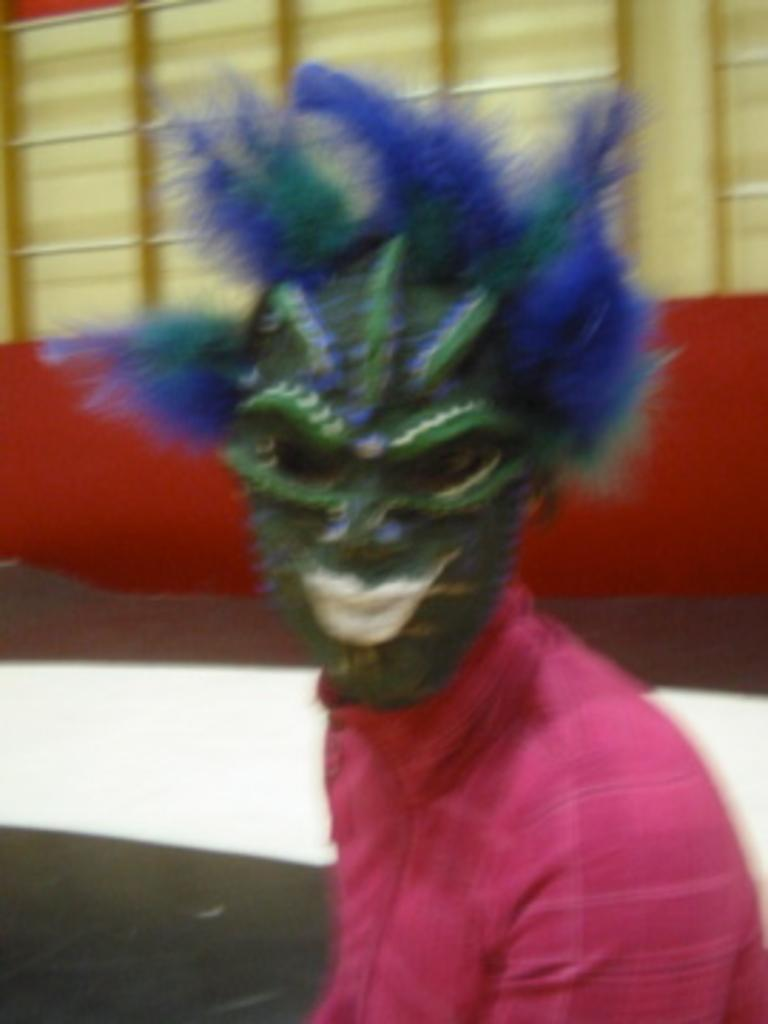Who or what is present in the image? There is a person in the image. What is the person wearing on their face? The person is wearing a mask. What can be seen behind the person in the image? There is a wall in the background of the image. How many kittens are balancing on the person's head in the image? There are no kittens present in the image, and therefore no kittens can be seen balancing on the person's head. 